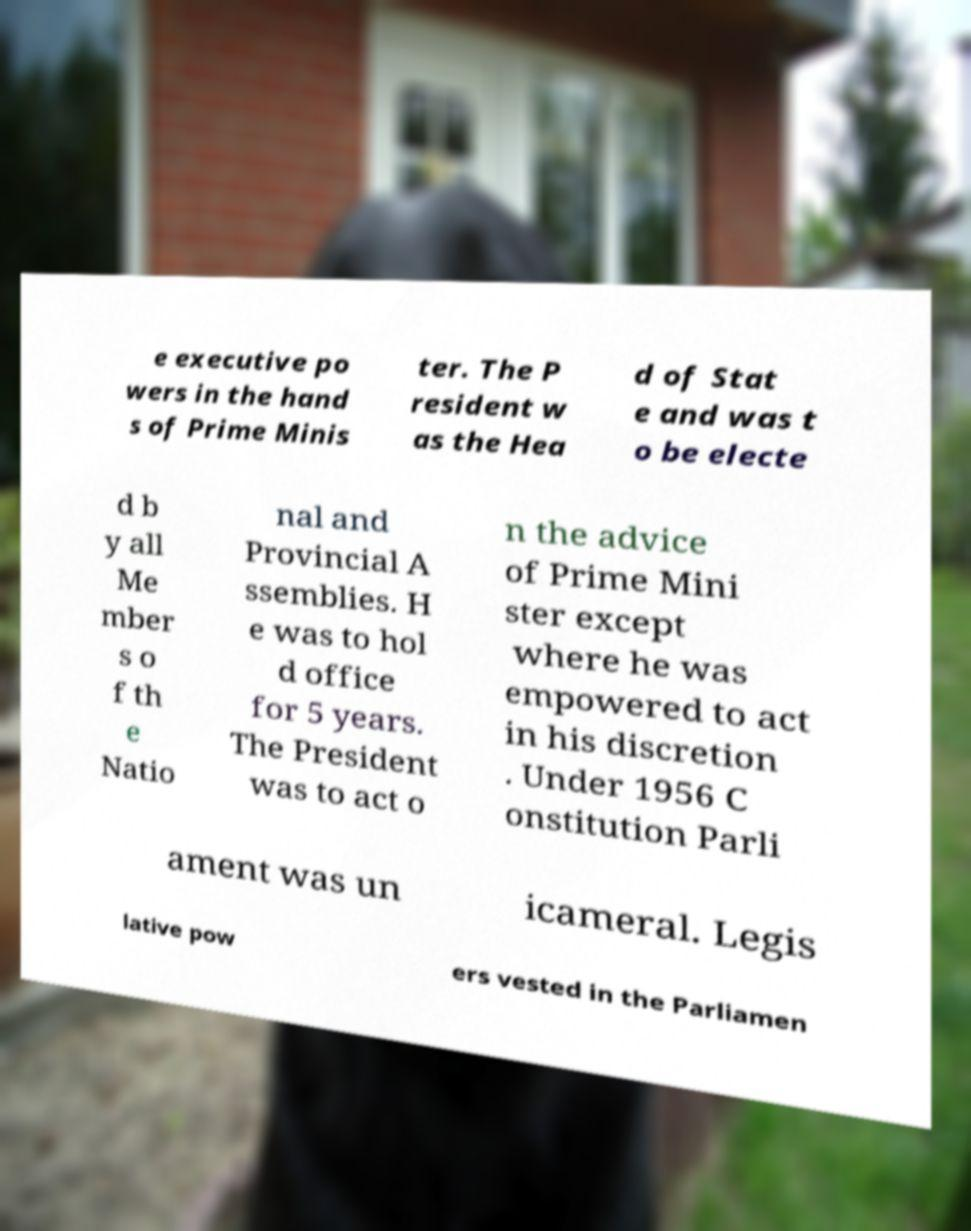Can you read and provide the text displayed in the image?This photo seems to have some interesting text. Can you extract and type it out for me? e executive po wers in the hand s of Prime Minis ter. The P resident w as the Hea d of Stat e and was t o be electe d b y all Me mber s o f th e Natio nal and Provincial A ssemblies. H e was to hol d office for 5 years. The President was to act o n the advice of Prime Mini ster except where he was empowered to act in his discretion . Under 1956 C onstitution Parli ament was un icameral. Legis lative pow ers vested in the Parliamen 